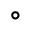<formula> <loc_0><loc_0><loc_500><loc_500>^ { \circ }</formula> 